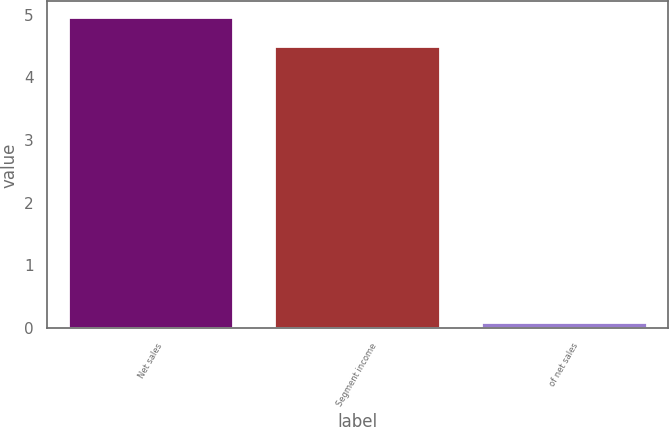Convert chart. <chart><loc_0><loc_0><loc_500><loc_500><bar_chart><fcel>Net sales<fcel>Segment income<fcel>of net sales<nl><fcel>4.96<fcel>4.5<fcel>0.1<nl></chart> 